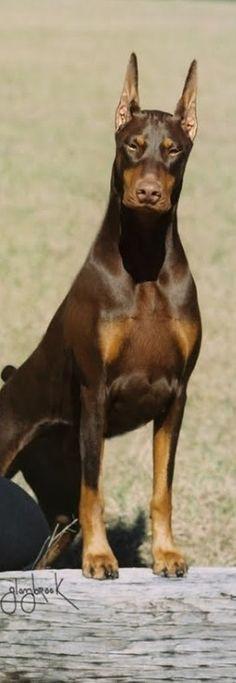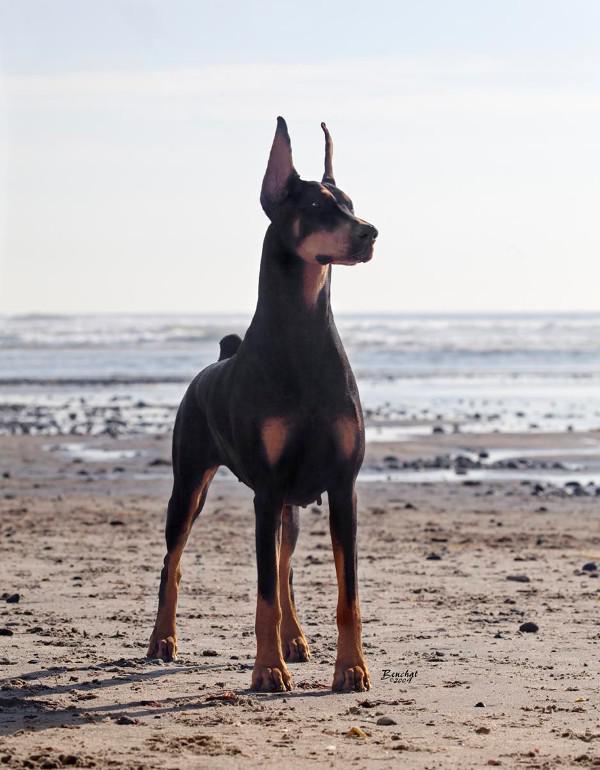The first image is the image on the left, the second image is the image on the right. For the images displayed, is the sentence "A doberman has its mouth open." factually correct? Answer yes or no. No. 